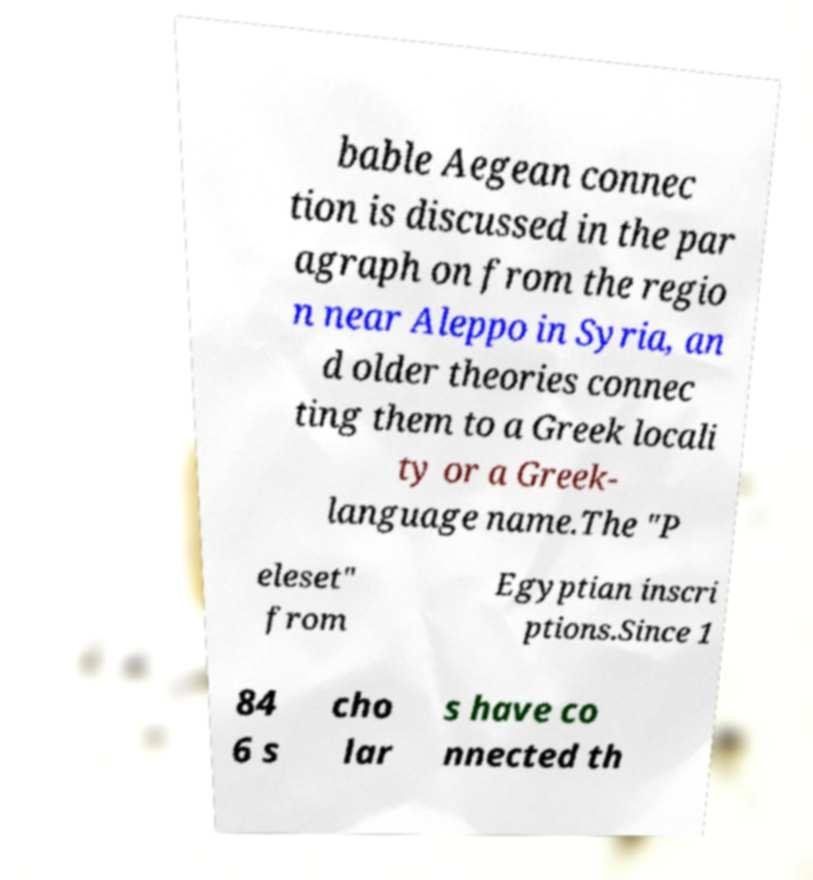I need the written content from this picture converted into text. Can you do that? bable Aegean connec tion is discussed in the par agraph on from the regio n near Aleppo in Syria, an d older theories connec ting them to a Greek locali ty or a Greek- language name.The "P eleset" from Egyptian inscri ptions.Since 1 84 6 s cho lar s have co nnected th 